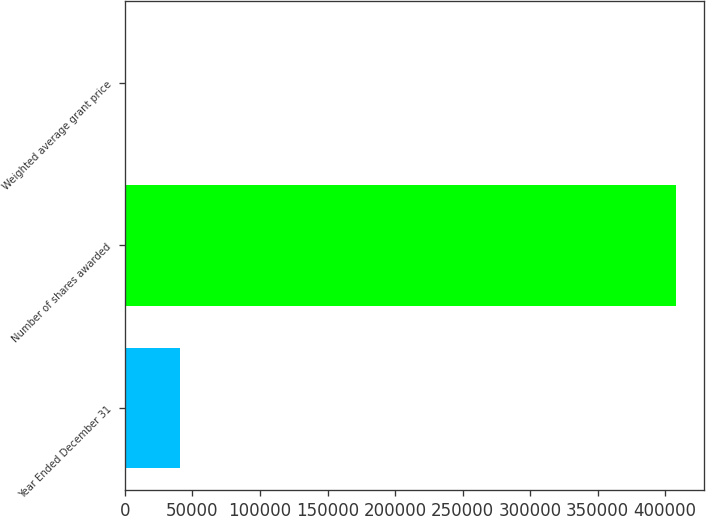<chart> <loc_0><loc_0><loc_500><loc_500><bar_chart><fcel>Year Ended December 31<fcel>Number of shares awarded<fcel>Weighted average grant price<nl><fcel>40859.1<fcel>408064<fcel>58.54<nl></chart> 